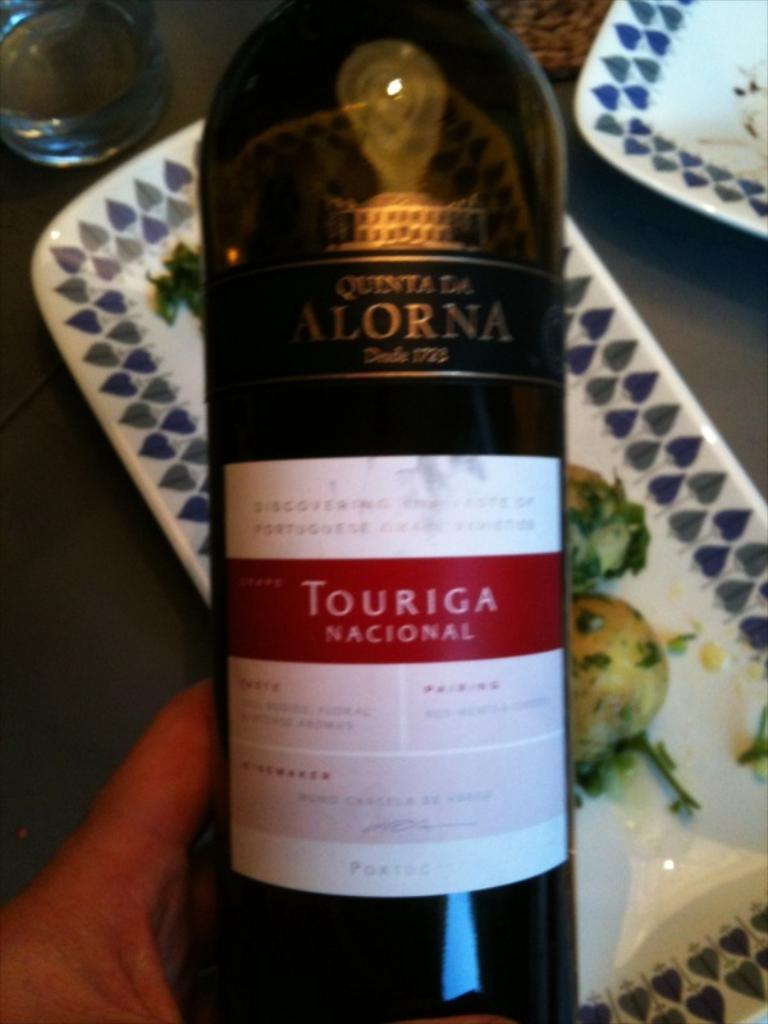What is the human hand in the image holding? The hand is holding a bottle. What can be seen on the bottle? There is a sticker on the bottle. What objects are visible in the background of the image? There are two trays and glasses on the surface in the background. What is on one of the trays? There is food on one of the trays. What type of flower is being distributed by the hand in the image? There is no flower present in the image; the hand is holding a bottle. Is the person in the image sleeping or awake? The image does not show a person, only a hand holding a bottle, so it is impossible to determine if the person is sleeping or awake. 